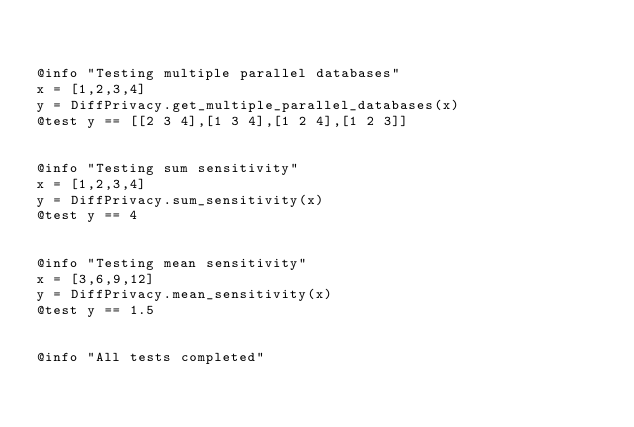<code> <loc_0><loc_0><loc_500><loc_500><_Julia_>

@info "Testing multiple parallel databases"
x = [1,2,3,4]
y = DiffPrivacy.get_multiple_parallel_databases(x)
@test y == [[2 3 4],[1 3 4],[1 2 4],[1 2 3]]


@info "Testing sum sensitivity"
x = [1,2,3,4]
y = DiffPrivacy.sum_sensitivity(x)
@test y == 4


@info "Testing mean sensitivity"
x = [3,6,9,12]
y = DiffPrivacy.mean_sensitivity(x)
@test y == 1.5


@info "All tests completed"
</code> 